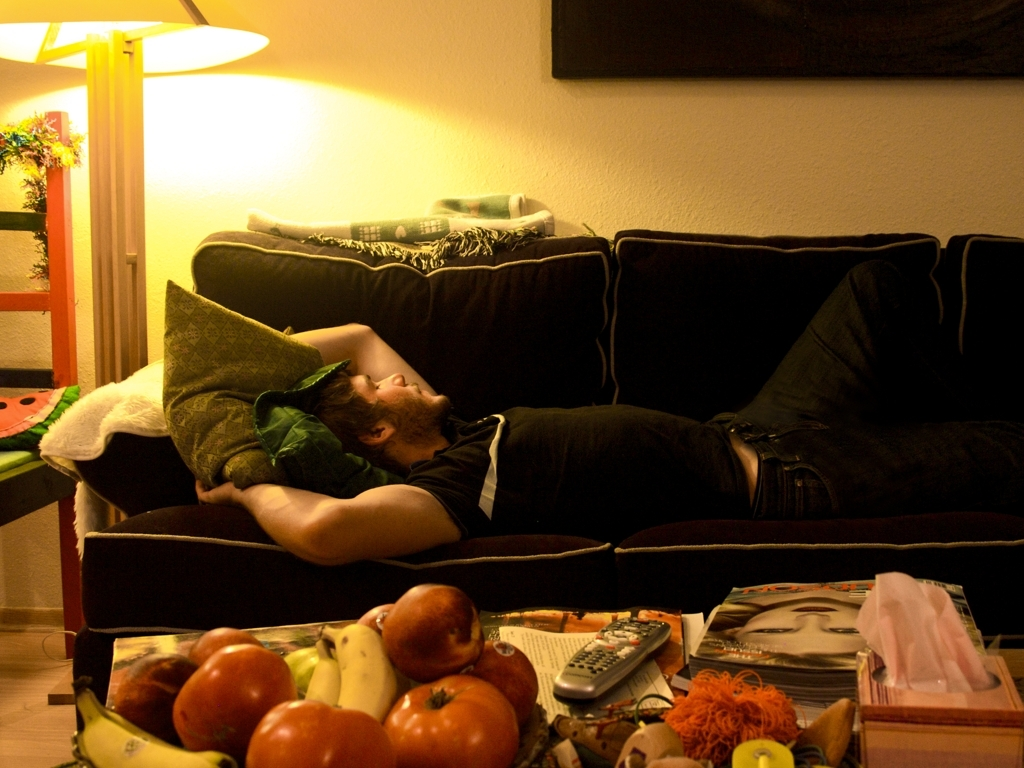Is the quality of the image high? The image is of decent quality with good lighting and clear details, though it does appear slightly grainy which may indicate it is not of the highest resolution. 